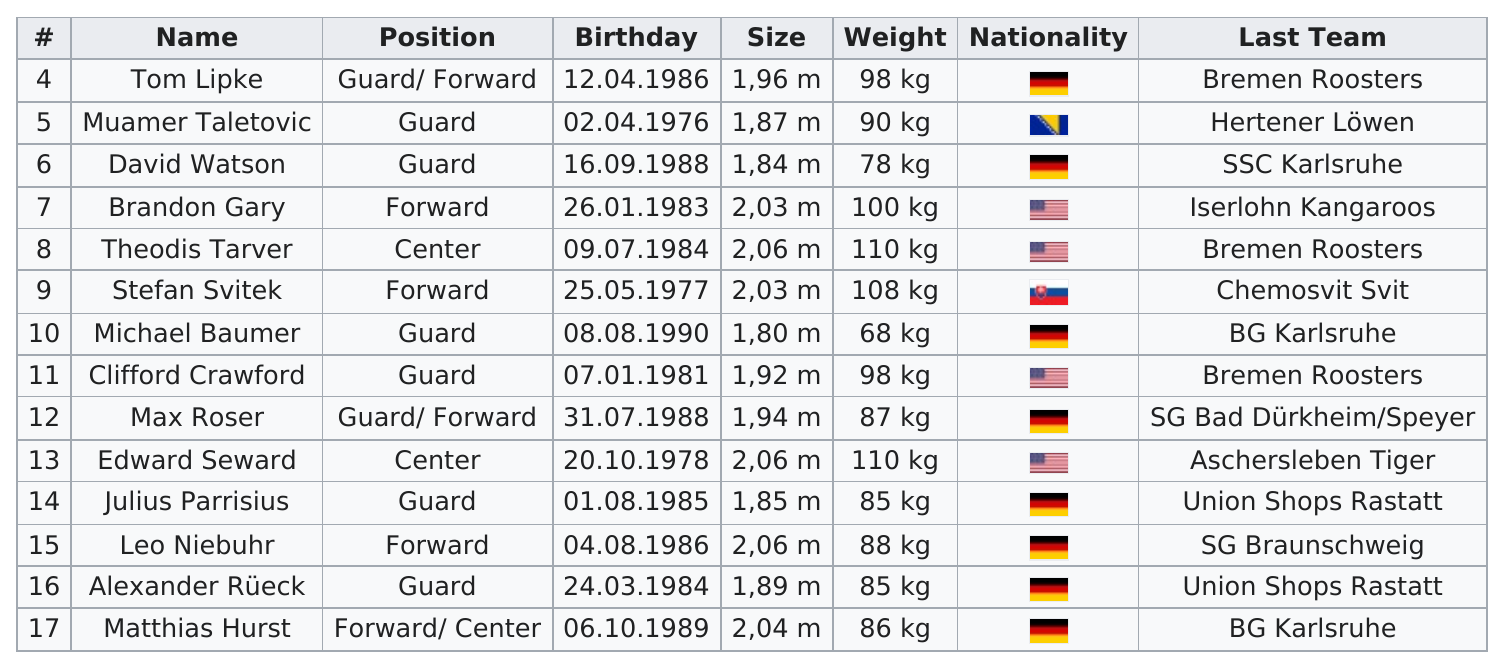Mention a couple of crucial points in this snapshot. Approximately three people were born before 1980. Stefan Svitek is the only player whose last team was Chemosvit Svit. He is that player. Eight players have German as their nationality. The maximum number of people who can be considered American is 4. Seven weights are at least 90 kg. 